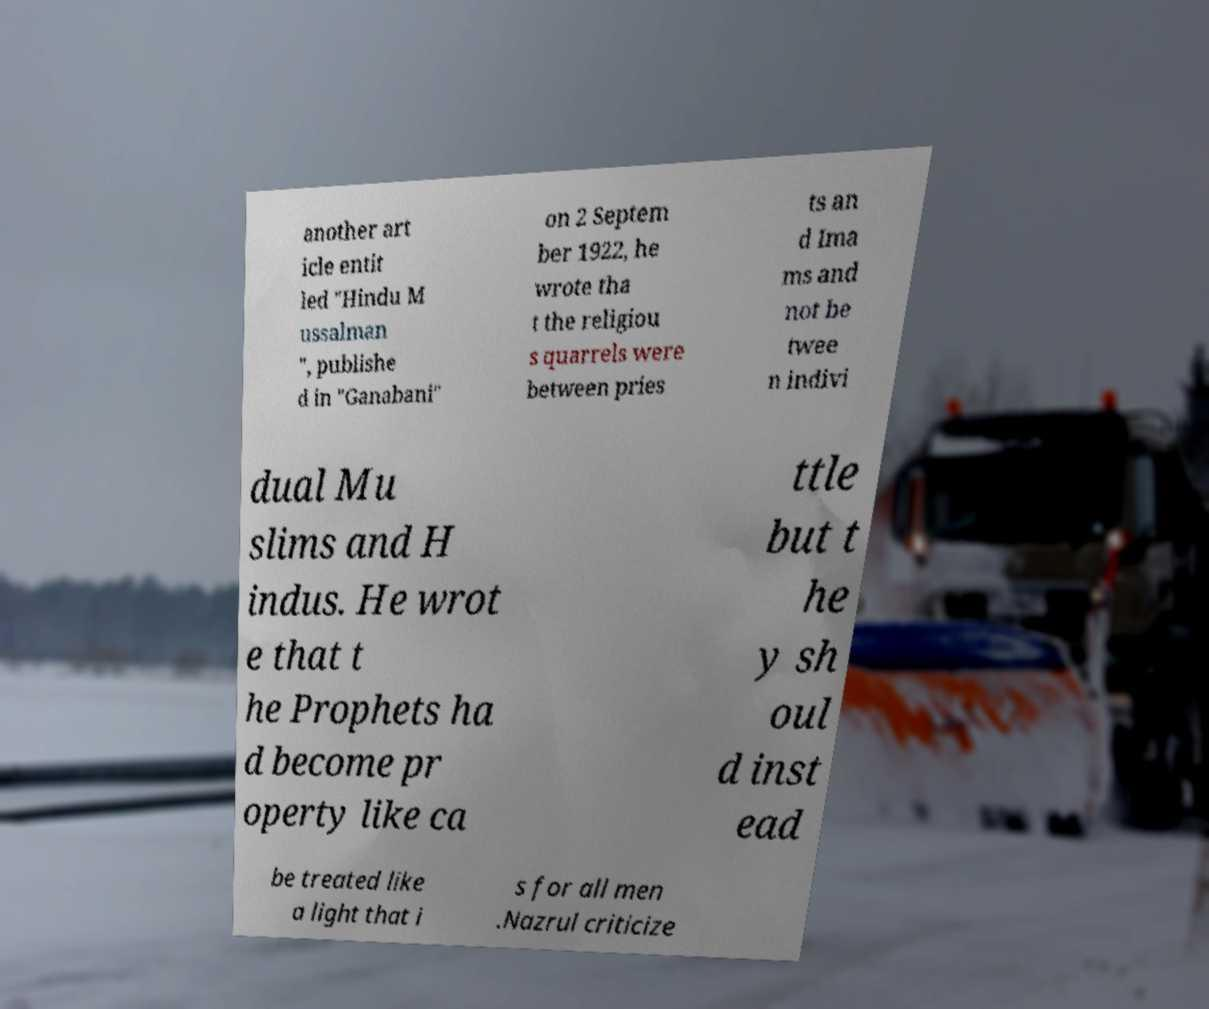I need the written content from this picture converted into text. Can you do that? another art icle entit led "Hindu M ussalman ", publishe d in "Ganabani" on 2 Septem ber 1922, he wrote tha t the religiou s quarrels were between pries ts an d Ima ms and not be twee n indivi dual Mu slims and H indus. He wrot e that t he Prophets ha d become pr operty like ca ttle but t he y sh oul d inst ead be treated like a light that i s for all men .Nazrul criticize 